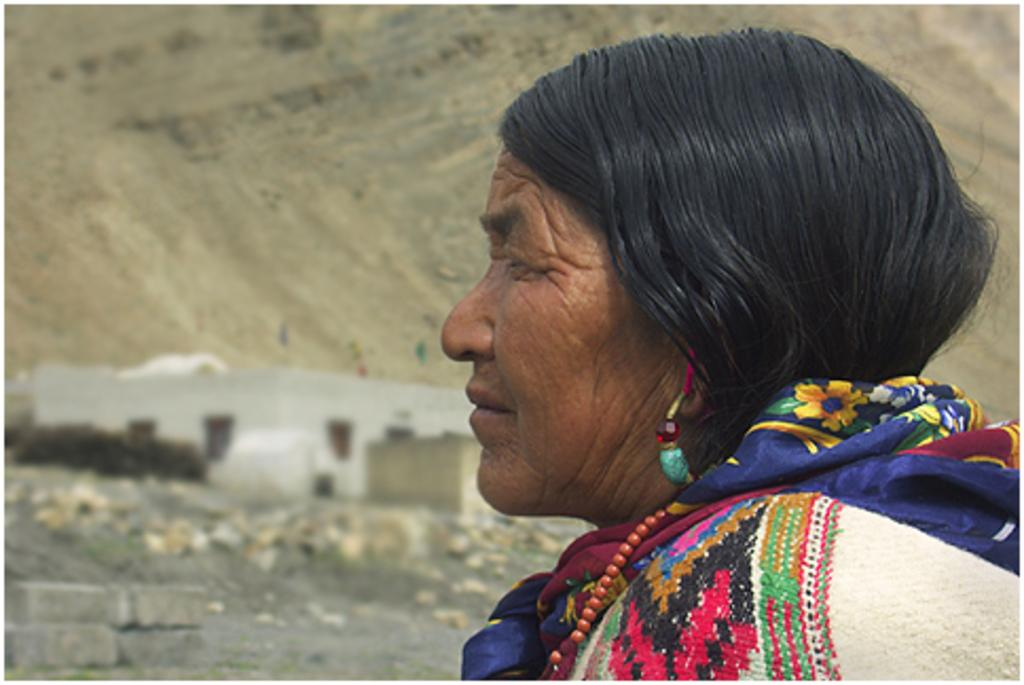Who is present in the image? There is a woman in the image. What can be seen in the background of the image? There is a building, a hill, and rocks in the background of the image. What type of line is visible on the hill in the image? There is no line visible on the hill in the image. 